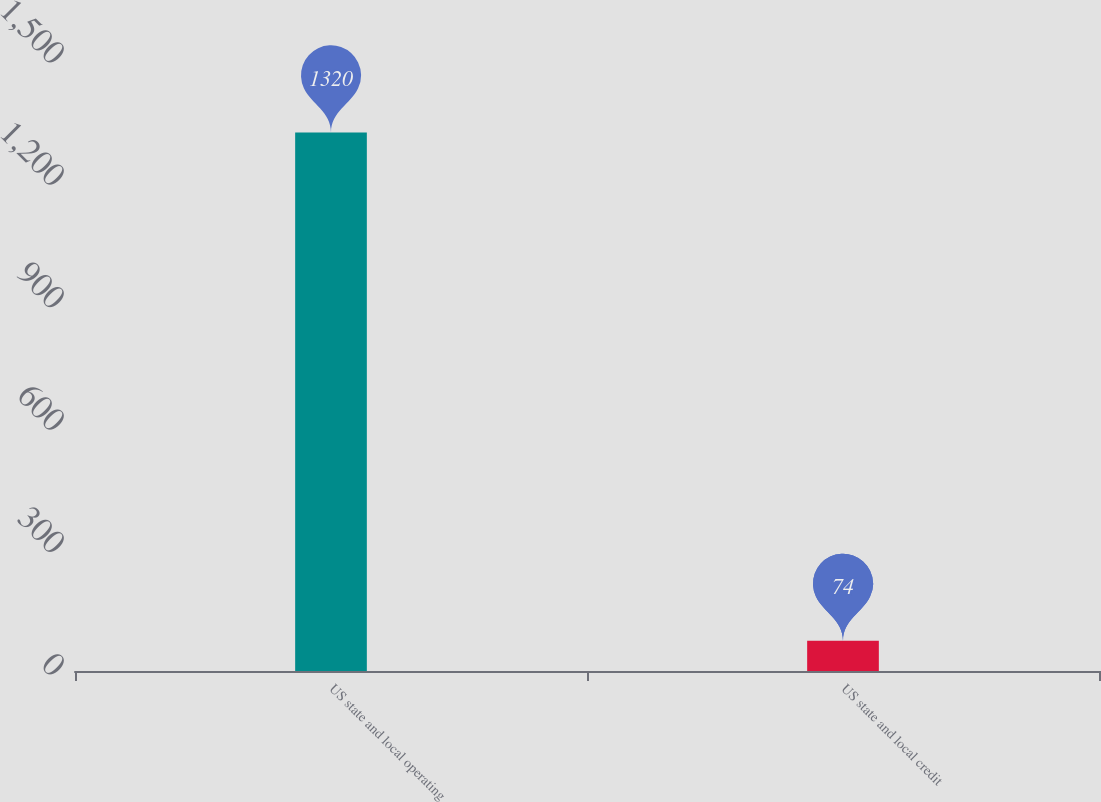Convert chart to OTSL. <chart><loc_0><loc_0><loc_500><loc_500><bar_chart><fcel>US state and local operating<fcel>US state and local credit<nl><fcel>1320<fcel>74<nl></chart> 